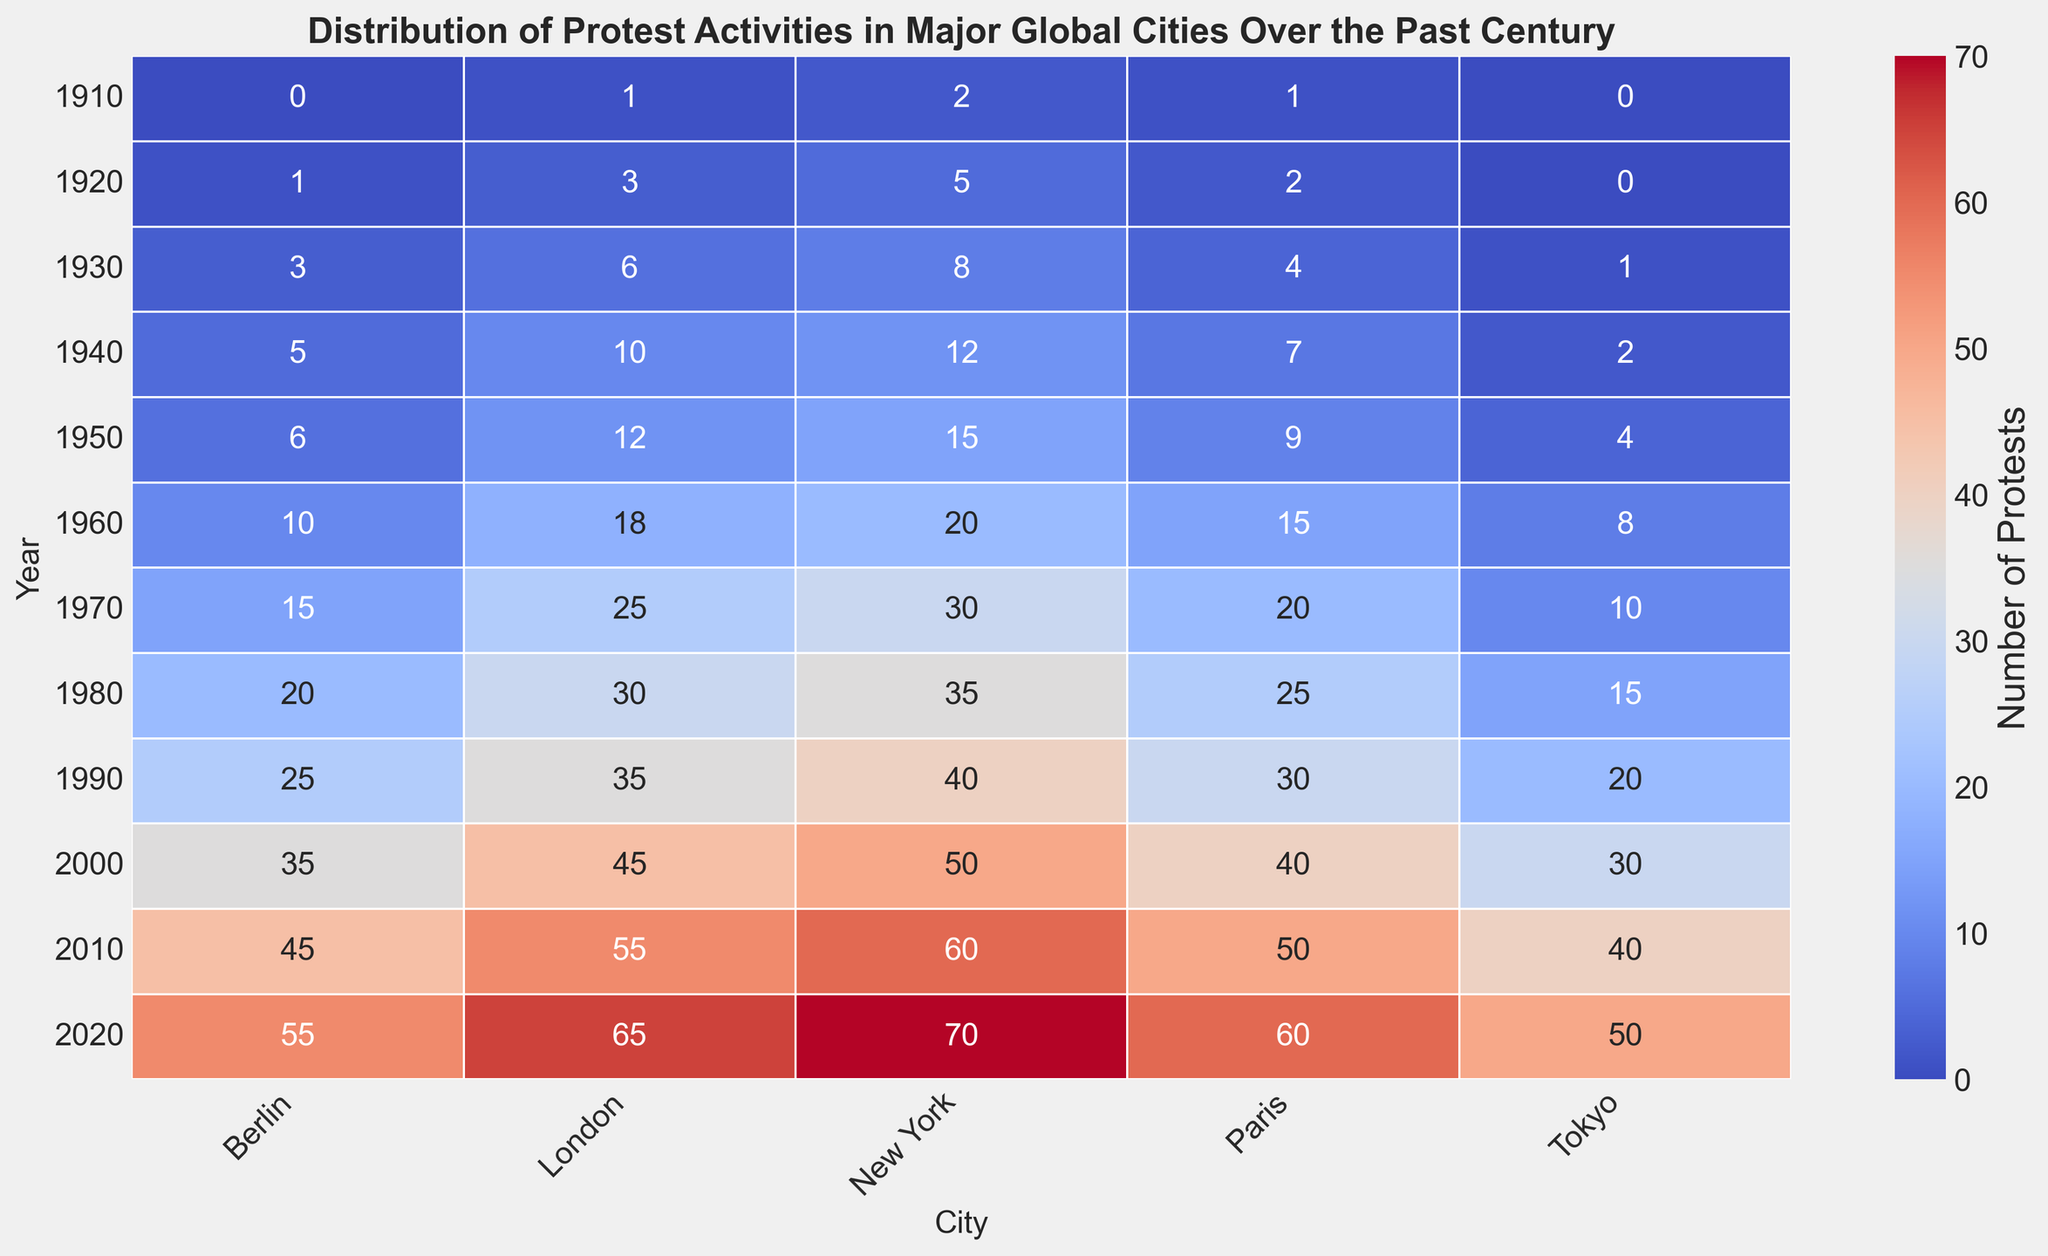When was the number of protests in Paris the highest? By scanning the row corresponding to Paris, the darkest red cell appears in 2020. Therefore, the highest number of protests in Paris was in 2020.
Answer: 2020 What is the total number of protests in Berlin over the past century? Summing up the number of protests in Berlin from the data, we get 0 + 1 + 3 + 5 + 6 + 10 + 15 + 20 + 25 + 35 + 45 + 55 = 220.
Answer: 220 Which city had the highest increase in protests from 1910 to 2020? Subtracting the number of protests in 1910 from 2020 for each city, New York increased by 70-2 = 68, London by 65-1 = 64, Paris by 60-1 = 59, Berlin by 55-0 = 55, Tokyo by 50-0 = 50. The highest increase is in New York.
Answer: New York In what year did Tokyo first have more than 20 protests? By examining the Tokyo column, we observe that Tokyo first surpasses 20 protests in the year 1990.
Answer: 1990 Which year had the highest number of total protests across all cities? Summing the number of protests across all cities for each year:
- 1910: 2 + 1 + 1 + 0 + 0 = 4
- 1920: 5 + 3 + 2 + 1 + 0 = 11
- 1930: 8 + 6 + 4 + 3 + 1 = 22
- 1940: 12 + 10 + 7 + 5 + 2 = 36
- 1950: 15 + 12 + 9 + 6 + 4 = 46
- 1960: 20 + 18 + 15 + 10 + 8 = 71
- 1970: 30 + 25 + 20 + 15 + 10 = 100
- 1980: 35 + 30 + 25 + 20 + 15 = 125
- 1990: 40 + 35 + 30 + 25 + 20 = 150
- 2000: 50 + 45 + 40 + 35 + 30 = 200
- 2010: 60 + 55 + 50 + 45 + 40 = 250
- 2020: 70 + 65 + 60 + 55 + 50 = 300
The highest total is in 2020 with 300 protests.
Answer: 2020 Which two cities have the smallest difference in the number of protests in 2010? The number of protests in 2010 for each city are New York: 60, London: 55, Paris: 50, Berlin: 45, Tokyo: 40. The smallest differences are between pairs (London and Paris) and (New York and London): 55 - 50 = 5 and 60 - 55 = 5. So, London and Paris or New York and London.
Answer: London and Paris or New York and London Which decade saw the largest increase in the average number of protests per city from the previous decade? Calculate the average protests per city for each decade and then find the difference between each consecutive decade:
- 1910: (2 + 1 + 1 + 0 + 0) / 5 = 0.8
- 1920: (5 + 3 + 2 + 1 + 0) / 5 = 2.2
- Difference (1920-1910): 2.2 - 0.8 = 1.4
- 1930: (8 + 6 + 4 + 3 + 1) / 5 = 4.4
- Difference (1930-1920): 4.4 - 2.2 = 2.2
- 1940: (12 + 10 + 7 + 5 + 2) / 5 = 7.2
- Difference (1940-1930): 7.2 - 4.4 = 2.8
- 1950: (15 + 12 + 9 + 6 + 4) / 5 = 9.2
- Difference (1950-1940): 9.2 - 7.2 = 2.0
- 1960: (20 + 18 + 15 + 10 + 8) / 5 = 14.2
- Difference (1960-1950): 14.2 - 9.2 = 5.0
- 1970: (30 + 25 + 20 + 15 + 10) / 5 = 20.0
- Difference (1970-1960): 20.0 - 14.2 = 5.8
- 1980: (35 + 30 + 25 + 20 + 15) / 5 = 25.0
- Difference (1980-1970): 25.0 - 20.0 = 5.0
- 1990: (40 + 35 + 30 + 25 + 20) / 5 = 30.0
- Difference (1990-1980): 30.0 - 25.0 = 5.0
- 2000: (50 + 45 + 40 + 35 + 30) / 5 = 40.0
- Difference (2000-1990): 40.0 - 30.0 = 10.0
- 2010: (60 + 55 + 50 + 45 + 40) / 5 = 50.0
- Difference (2010-2000): 50.0 - 40.0 = 10.0
- 2020: (70 + 65 + 60 + 55 + 50) / 5 = 60.0
- Difference (2020-2010): 60.0 - 50.0 = 10.0
The largest increase is from the 1990s to the 2000s and the 2000s to the 2010s, both 10.0.
Answer: 2000 What is the average number of protests in Tokyo over the past century? Adding the number of protests in Tokyo for each year and then dividing by the number of years: (0 + 0 + 1 + 2 + 4 + 8 + 10 + 15 + 20 + 30 + 40 + 50) / 12 = 15.
Answer: 15 